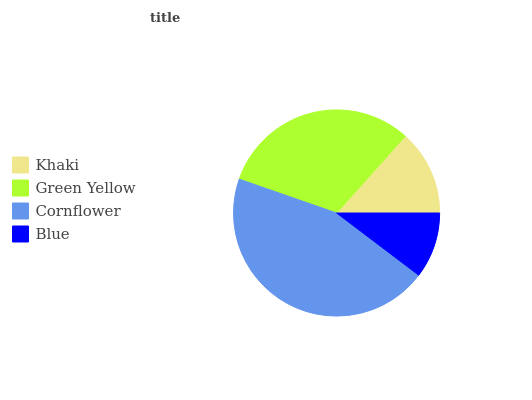Is Blue the minimum?
Answer yes or no. Yes. Is Cornflower the maximum?
Answer yes or no. Yes. Is Green Yellow the minimum?
Answer yes or no. No. Is Green Yellow the maximum?
Answer yes or no. No. Is Green Yellow greater than Khaki?
Answer yes or no. Yes. Is Khaki less than Green Yellow?
Answer yes or no. Yes. Is Khaki greater than Green Yellow?
Answer yes or no. No. Is Green Yellow less than Khaki?
Answer yes or no. No. Is Green Yellow the high median?
Answer yes or no. Yes. Is Khaki the low median?
Answer yes or no. Yes. Is Blue the high median?
Answer yes or no. No. Is Cornflower the low median?
Answer yes or no. No. 